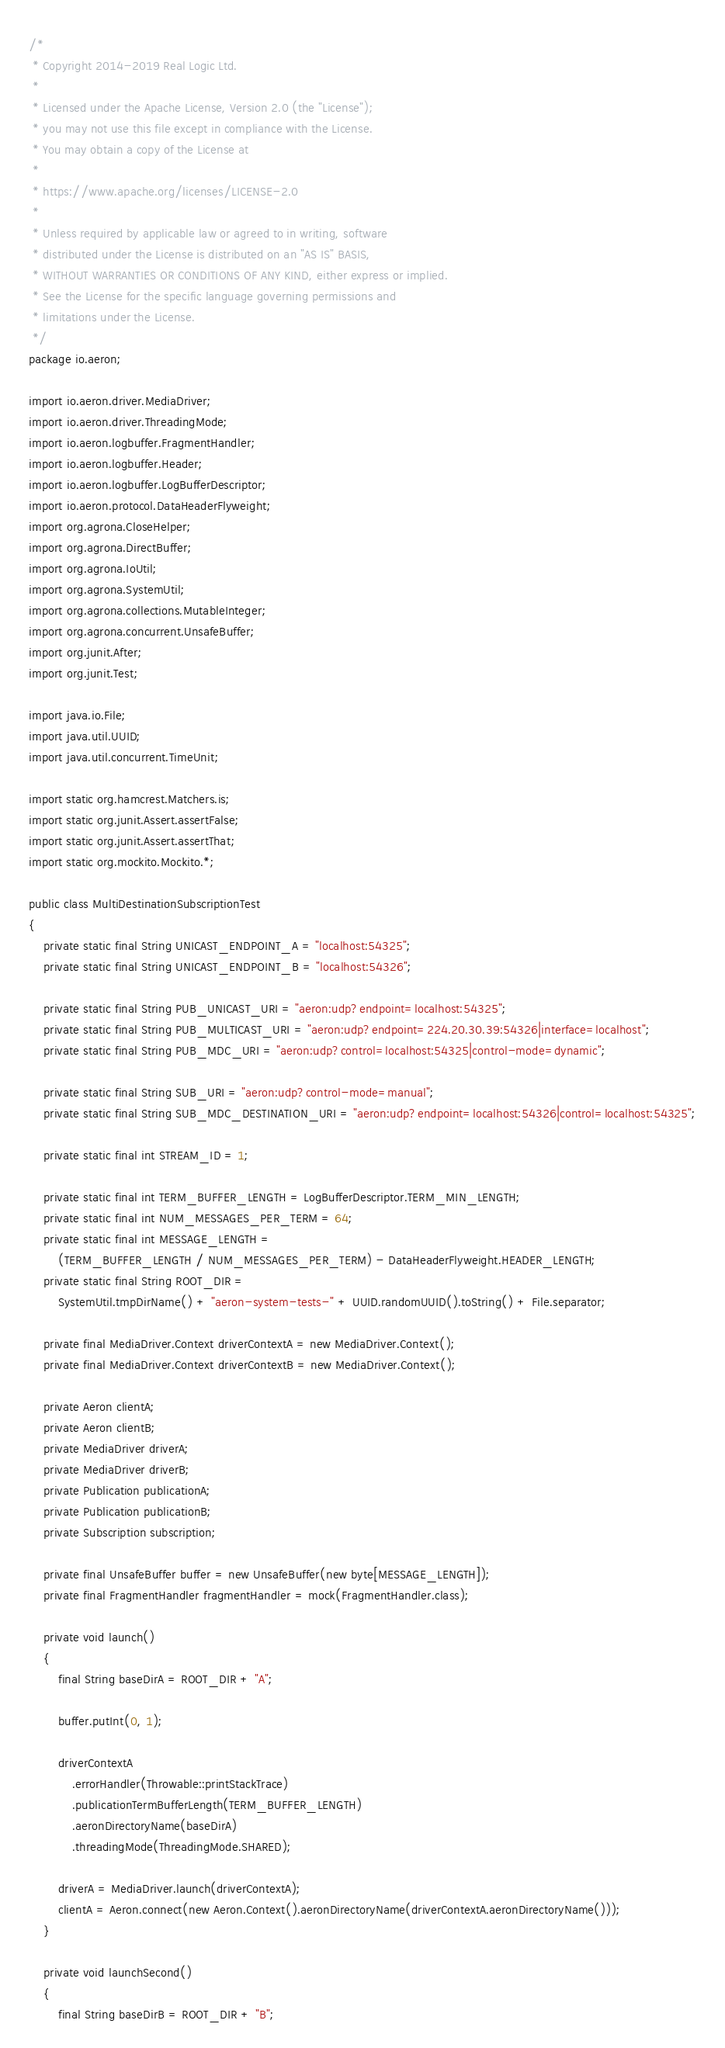<code> <loc_0><loc_0><loc_500><loc_500><_Java_>/*
 * Copyright 2014-2019 Real Logic Ltd.
 *
 * Licensed under the Apache License, Version 2.0 (the "License");
 * you may not use this file except in compliance with the License.
 * You may obtain a copy of the License at
 *
 * https://www.apache.org/licenses/LICENSE-2.0
 *
 * Unless required by applicable law or agreed to in writing, software
 * distributed under the License is distributed on an "AS IS" BASIS,
 * WITHOUT WARRANTIES OR CONDITIONS OF ANY KIND, either express or implied.
 * See the License for the specific language governing permissions and
 * limitations under the License.
 */
package io.aeron;

import io.aeron.driver.MediaDriver;
import io.aeron.driver.ThreadingMode;
import io.aeron.logbuffer.FragmentHandler;
import io.aeron.logbuffer.Header;
import io.aeron.logbuffer.LogBufferDescriptor;
import io.aeron.protocol.DataHeaderFlyweight;
import org.agrona.CloseHelper;
import org.agrona.DirectBuffer;
import org.agrona.IoUtil;
import org.agrona.SystemUtil;
import org.agrona.collections.MutableInteger;
import org.agrona.concurrent.UnsafeBuffer;
import org.junit.After;
import org.junit.Test;

import java.io.File;
import java.util.UUID;
import java.util.concurrent.TimeUnit;

import static org.hamcrest.Matchers.is;
import static org.junit.Assert.assertFalse;
import static org.junit.Assert.assertThat;
import static org.mockito.Mockito.*;

public class MultiDestinationSubscriptionTest
{
    private static final String UNICAST_ENDPOINT_A = "localhost:54325";
    private static final String UNICAST_ENDPOINT_B = "localhost:54326";

    private static final String PUB_UNICAST_URI = "aeron:udp?endpoint=localhost:54325";
    private static final String PUB_MULTICAST_URI = "aeron:udp?endpoint=224.20.30.39:54326|interface=localhost";
    private static final String PUB_MDC_URI = "aeron:udp?control=localhost:54325|control-mode=dynamic";

    private static final String SUB_URI = "aeron:udp?control-mode=manual";
    private static final String SUB_MDC_DESTINATION_URI = "aeron:udp?endpoint=localhost:54326|control=localhost:54325";

    private static final int STREAM_ID = 1;

    private static final int TERM_BUFFER_LENGTH = LogBufferDescriptor.TERM_MIN_LENGTH;
    private static final int NUM_MESSAGES_PER_TERM = 64;
    private static final int MESSAGE_LENGTH =
        (TERM_BUFFER_LENGTH / NUM_MESSAGES_PER_TERM) - DataHeaderFlyweight.HEADER_LENGTH;
    private static final String ROOT_DIR =
        SystemUtil.tmpDirName() + "aeron-system-tests-" + UUID.randomUUID().toString() + File.separator;

    private final MediaDriver.Context driverContextA = new MediaDriver.Context();
    private final MediaDriver.Context driverContextB = new MediaDriver.Context();

    private Aeron clientA;
    private Aeron clientB;
    private MediaDriver driverA;
    private MediaDriver driverB;
    private Publication publicationA;
    private Publication publicationB;
    private Subscription subscription;

    private final UnsafeBuffer buffer = new UnsafeBuffer(new byte[MESSAGE_LENGTH]);
    private final FragmentHandler fragmentHandler = mock(FragmentHandler.class);

    private void launch()
    {
        final String baseDirA = ROOT_DIR + "A";

        buffer.putInt(0, 1);

        driverContextA
            .errorHandler(Throwable::printStackTrace)
            .publicationTermBufferLength(TERM_BUFFER_LENGTH)
            .aeronDirectoryName(baseDirA)
            .threadingMode(ThreadingMode.SHARED);

        driverA = MediaDriver.launch(driverContextA);
        clientA = Aeron.connect(new Aeron.Context().aeronDirectoryName(driverContextA.aeronDirectoryName()));
    }

    private void launchSecond()
    {
        final String baseDirB = ROOT_DIR + "B";
</code> 